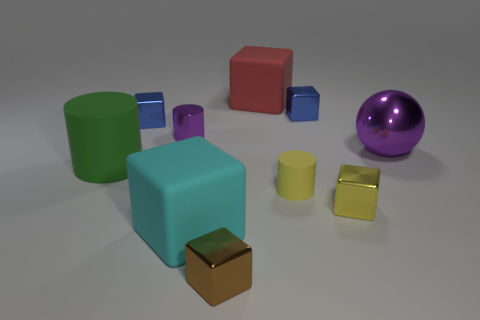There is a thing that is the same color as the large metallic sphere; what shape is it?
Offer a terse response. Cylinder. Is the number of small cubes behind the large purple metal sphere less than the number of small matte things?
Offer a very short reply. No. Are there more green objects that are to the right of the yellow rubber cylinder than small metal objects behind the cyan block?
Keep it short and to the point. No. Is there anything else that has the same color as the tiny metal cylinder?
Your answer should be compact. Yes. What material is the cylinder behind the green object?
Provide a short and direct response. Metal. Is the brown block the same size as the purple metal sphere?
Ensure brevity in your answer.  No. How many other objects are there of the same size as the sphere?
Your response must be concise. 3. Does the metal cylinder have the same color as the large rubber cylinder?
Make the answer very short. No. The object behind the blue shiny block that is behind the small blue thing on the left side of the large cyan cube is what shape?
Ensure brevity in your answer.  Cube. What number of objects are either big matte objects behind the tiny yellow shiny object or small cubes that are behind the tiny yellow shiny thing?
Offer a terse response. 4. 